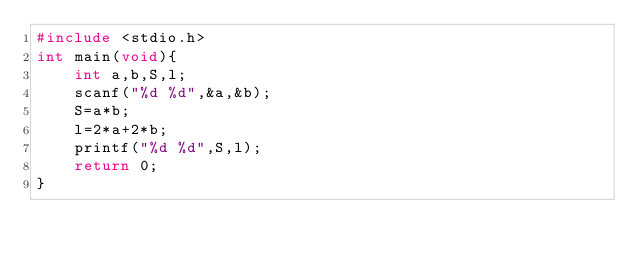Convert code to text. <code><loc_0><loc_0><loc_500><loc_500><_C_>#include <stdio.h>
int main(void){
    int a,b,S,l;
    scanf("%d %d",&a,&b);
    S=a*b;
    l=2*a+2*b;
    printf("%d %d",S,l);
    return 0;
}
</code> 